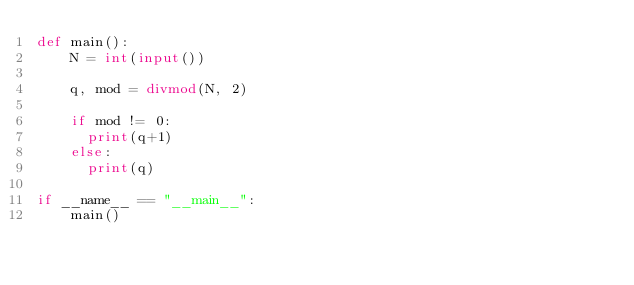<code> <loc_0><loc_0><loc_500><loc_500><_Python_>def main():
    N = int(input())

    q, mod = divmod(N, 2)

    if mod != 0:
      print(q+1)
    else:
      print(q)

if __name__ == "__main__":
    main()</code> 